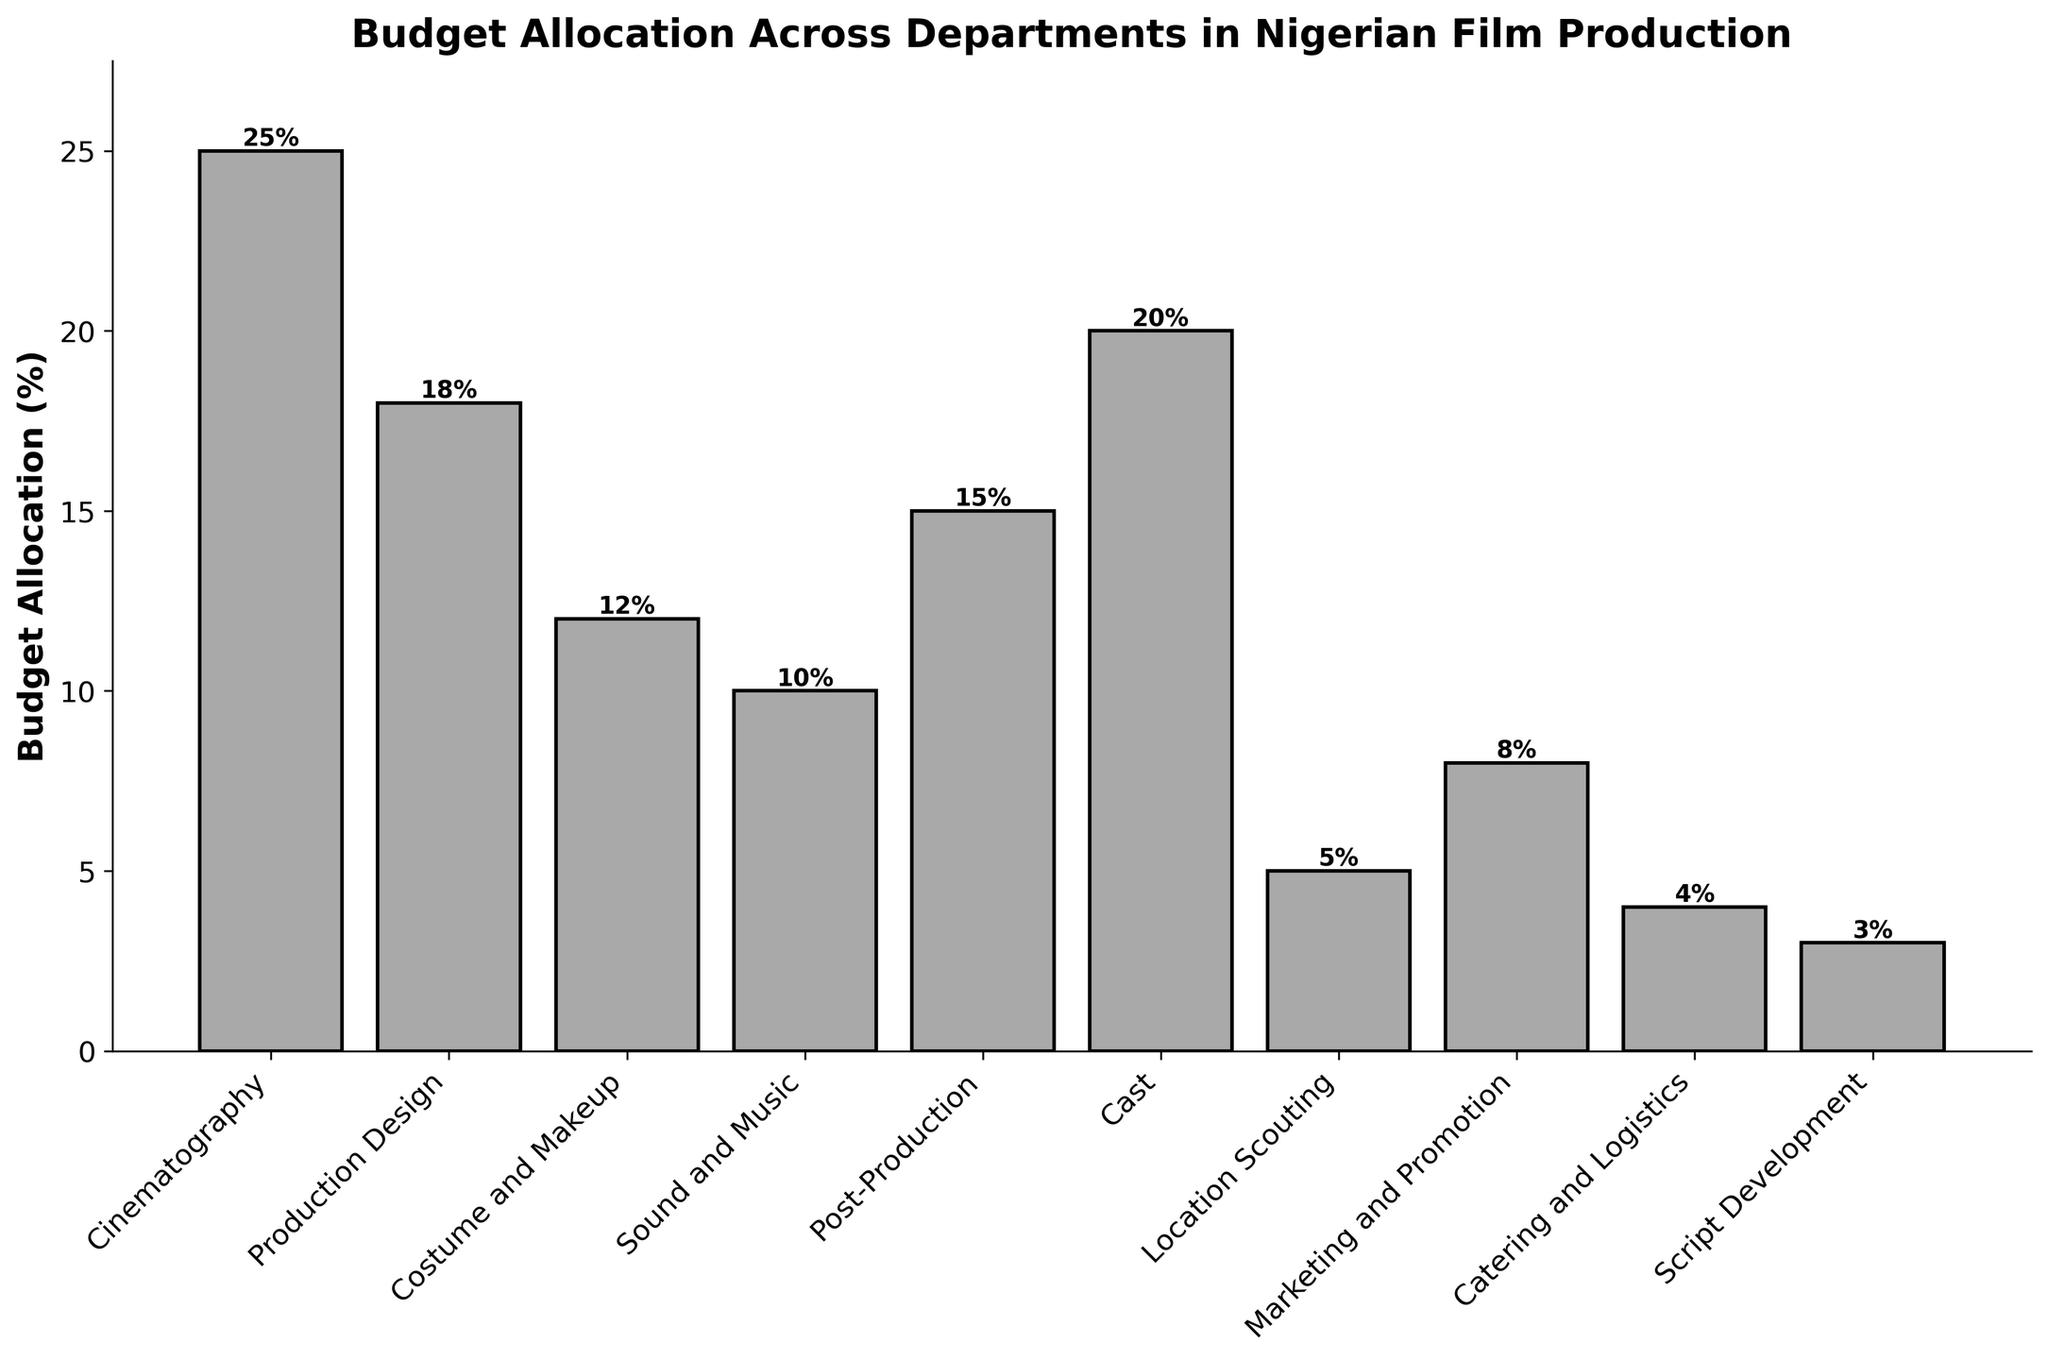What department has the highest budget allocation? By looking at the figure, identify the tallest bar. The tallest bar represents Cinematography with a budget allocation of 25%.
Answer: Cinematography Which departments have a budget allocation greater than 15%? Identify all bars taller than the 15% line on the y-axis. These are Cinematography (25%), Cast (20%), Production Design (18%), and Post-Production (15%).
Answer: Cinematography, Cast, Production Design, Post-Production What is the total budget allocation for Script Development, Catering and Logistics, and Location Scouting combined? Add their budget allocations: Script Development (3%) + Catering and Logistics (4%) + Location Scouting (5%) = 12%.
Answer: 12% How much more budget is allocated to Cast than to Costume and Makeup? Subtract the budget allocation of Costume and Makeup from Cast: 20% - 12% = 8%.
Answer: 8% Which department has the lowest budget allocation? By looking at the figure, identify the shortest bar. The shortest bar represents Script Development with a budget allocation of 3%.
Answer: Script Development Compare the combined budget allocation for Sound and Music, and Marketing and Promotion with the allocation for Cinematography. Which is greater? Calculate the total and compare: Sound and Music (10%) + Marketing and Promotion (8%) = 18%. Cinematography = 25%. Cinematography is greater.
Answer: Cinematography What is the average budget allocation for Production Design, Costume and Makeup, and Cast? Add their budget allocations and divide by 3: (18% + 12% + 20%) / 3 = 50% / 3 ≈ 16.67%.
Answer: 16.67% How much less is the budget allocation for Catering and Logistics compared to Post-Production? Subtract the budget allocation of Catering and Logistics from Post-Production: 15% - 4% = 11%.
Answer: 11% If you were to increase the budget of Marketing and Promotion by 3%, what would be the new budget allocation? Add 3% to Marketing and Promotion's current allocation: 8% + 3% = 11%.
Answer: 11% What is the median budget allocation of the departments listed? To find the median, order the budget allocations: 3%, 4%, 5%, 8%, 10%, 12%, 15%, 18%, 20%, 25%. The middle values are 10% and 12%, so the median is (10% + 12%) / 2 = 11%.
Answer: 11% 